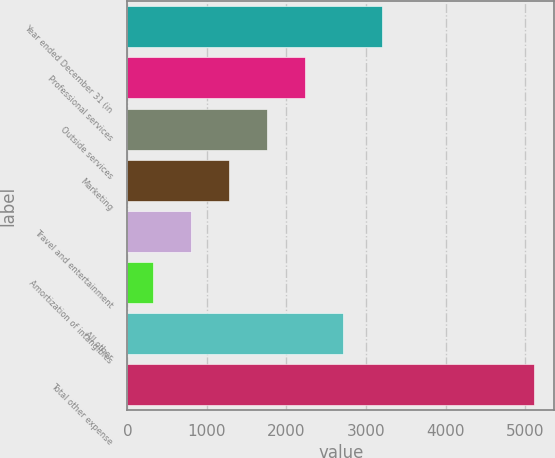Convert chart. <chart><loc_0><loc_0><loc_500><loc_500><bar_chart><fcel>Year ended December 31 (in<fcel>Professional services<fcel>Outside services<fcel>Marketing<fcel>Travel and entertainment<fcel>Amortization of intangibles<fcel>All other<fcel>Total other expense<nl><fcel>3195.8<fcel>2238.2<fcel>1759.4<fcel>1280.6<fcel>801.8<fcel>323<fcel>2717<fcel>5111<nl></chart> 